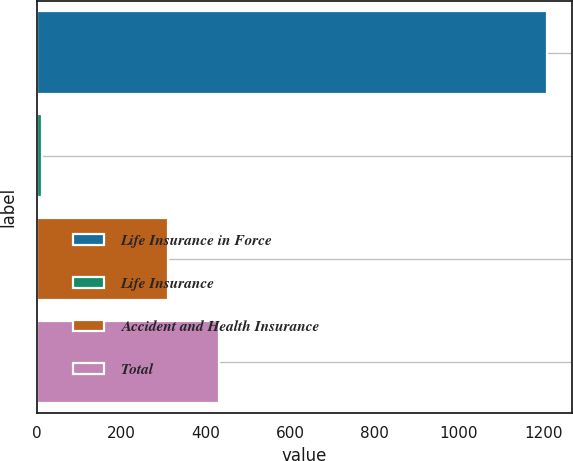<chart> <loc_0><loc_0><loc_500><loc_500><bar_chart><fcel>Life Insurance in Force<fcel>Life Insurance<fcel>Accident and Health Insurance<fcel>Total<nl><fcel>1208<fcel>12.7<fcel>311.6<fcel>431.13<nl></chart> 